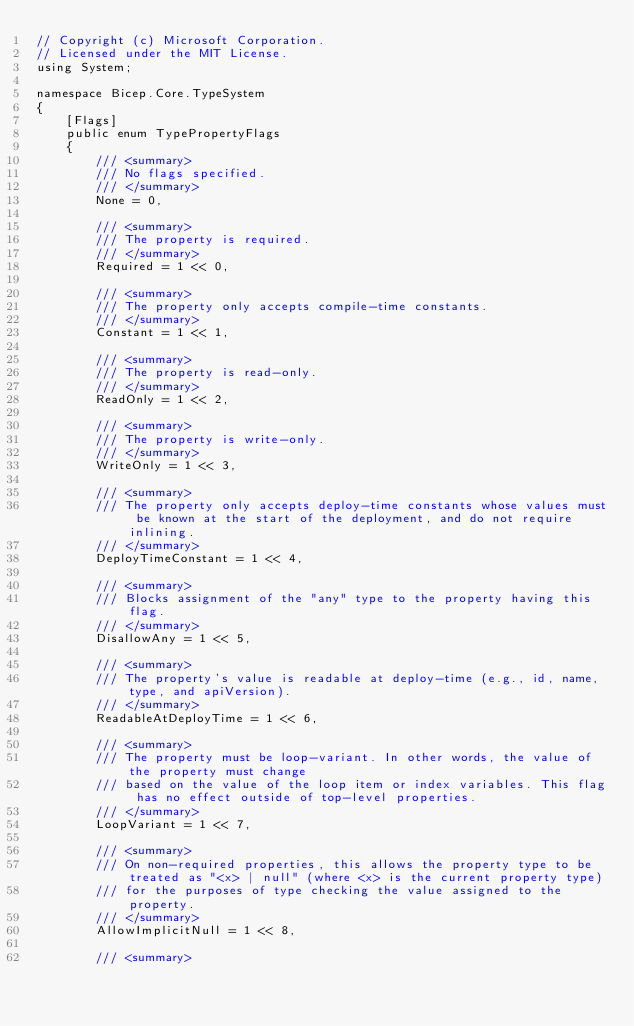Convert code to text. <code><loc_0><loc_0><loc_500><loc_500><_C#_>// Copyright (c) Microsoft Corporation.
// Licensed under the MIT License.
using System;

namespace Bicep.Core.TypeSystem
{
    [Flags]
    public enum TypePropertyFlags
    {
        /// <summary>
        /// No flags specified.
        /// </summary>
        None = 0,

        /// <summary>
        /// The property is required.
        /// </summary>
        Required = 1 << 0,

        /// <summary>
        /// The property only accepts compile-time constants.
        /// </summary>
        Constant = 1 << 1,

        /// <summary>
        /// The property is read-only.
        /// </summary>
        ReadOnly = 1 << 2,

        /// <summary>
        /// The property is write-only.
        /// </summary>
        WriteOnly = 1 << 3,

        /// <summary>
        /// The property only accepts deploy-time constants whose values must be known at the start of the deployment, and do not require inlining.
        /// </summary>
        DeployTimeConstant = 1 << 4,

        /// <summary>
        /// Blocks assignment of the "any" type to the property having this flag.
        /// </summary>
        DisallowAny = 1 << 5,

        /// <summary>
        /// The property's value is readable at deploy-time (e.g., id, name, type, and apiVersion).
        /// </summary>
        ReadableAtDeployTime = 1 << 6,

        /// <summary>
        /// The property must be loop-variant. In other words, the value of the property must change
        /// based on the value of the loop item or index variables. This flag has no effect outside of top-level properties.
        /// </summary>
        LoopVariant = 1 << 7,

        /// <summary>
        /// On non-required properties, this allows the property type to be treated as "<x> | null" (where <x> is the current property type)
        /// for the purposes of type checking the value assigned to the property.
        /// </summary>
        AllowImplicitNull = 1 << 8,

        /// <summary></code> 